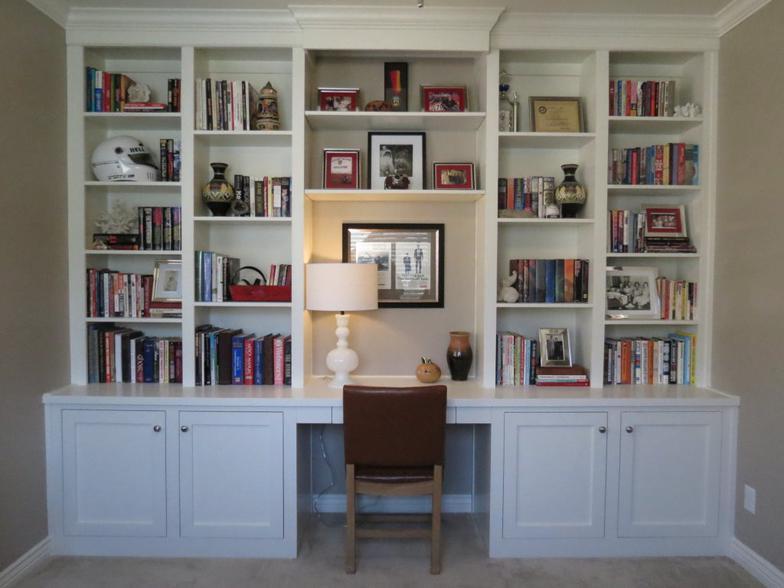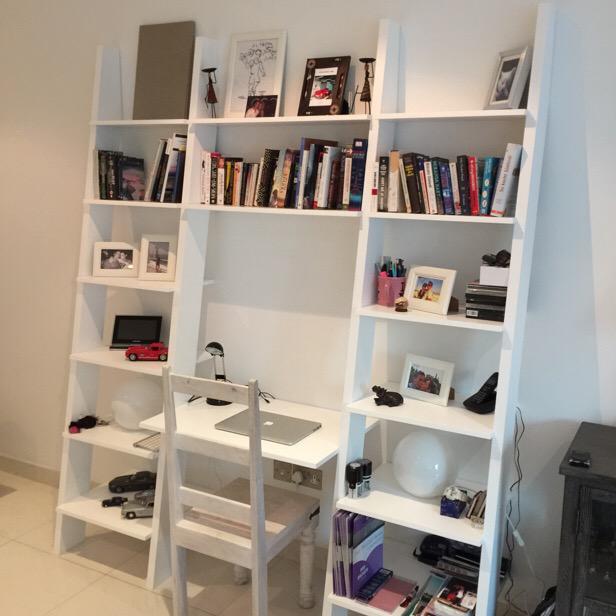The first image is the image on the left, the second image is the image on the right. Considering the images on both sides, is "There is a four legged chair at each of the white desk areas." valid? Answer yes or no. Yes. The first image is the image on the left, the second image is the image on the right. Analyze the images presented: Is the assertion "One bookcase nearly fills a wall and has a counter in the center flanked by at least two rows of shelves and two cabinets on either side." valid? Answer yes or no. Yes. 